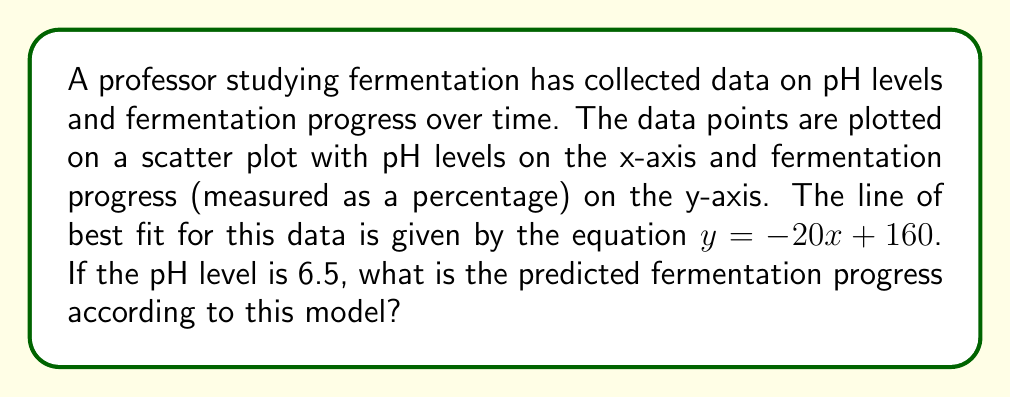Solve this math problem. To solve this problem, we need to use the given equation of the line of best fit and substitute the known pH value. Let's break it down step-by-step:

1. The equation of the line of best fit is:
   $y = -20x + 160$

   Where:
   $y$ represents the fermentation progress (%)
   $x$ represents the pH level

2. We are given that the pH level is 6.5, so $x = 6.5$

3. Let's substitute this value into the equation:
   $y = -20(6.5) + 160$

4. Now, let's solve the equation:
   $y = -130 + 160$
   $y = 30$

5. Therefore, when the pH level is 6.5, the predicted fermentation progress is 30%.

This result suggests an inverse relationship between pH levels and fermentation progress, which aligns with the typical behavior of many fermentation processes. As pH increases, the fermentation progress tends to decrease, likely due to the sensitivity of fermentation microorganisms to changes in acidity.
Answer: 30% 